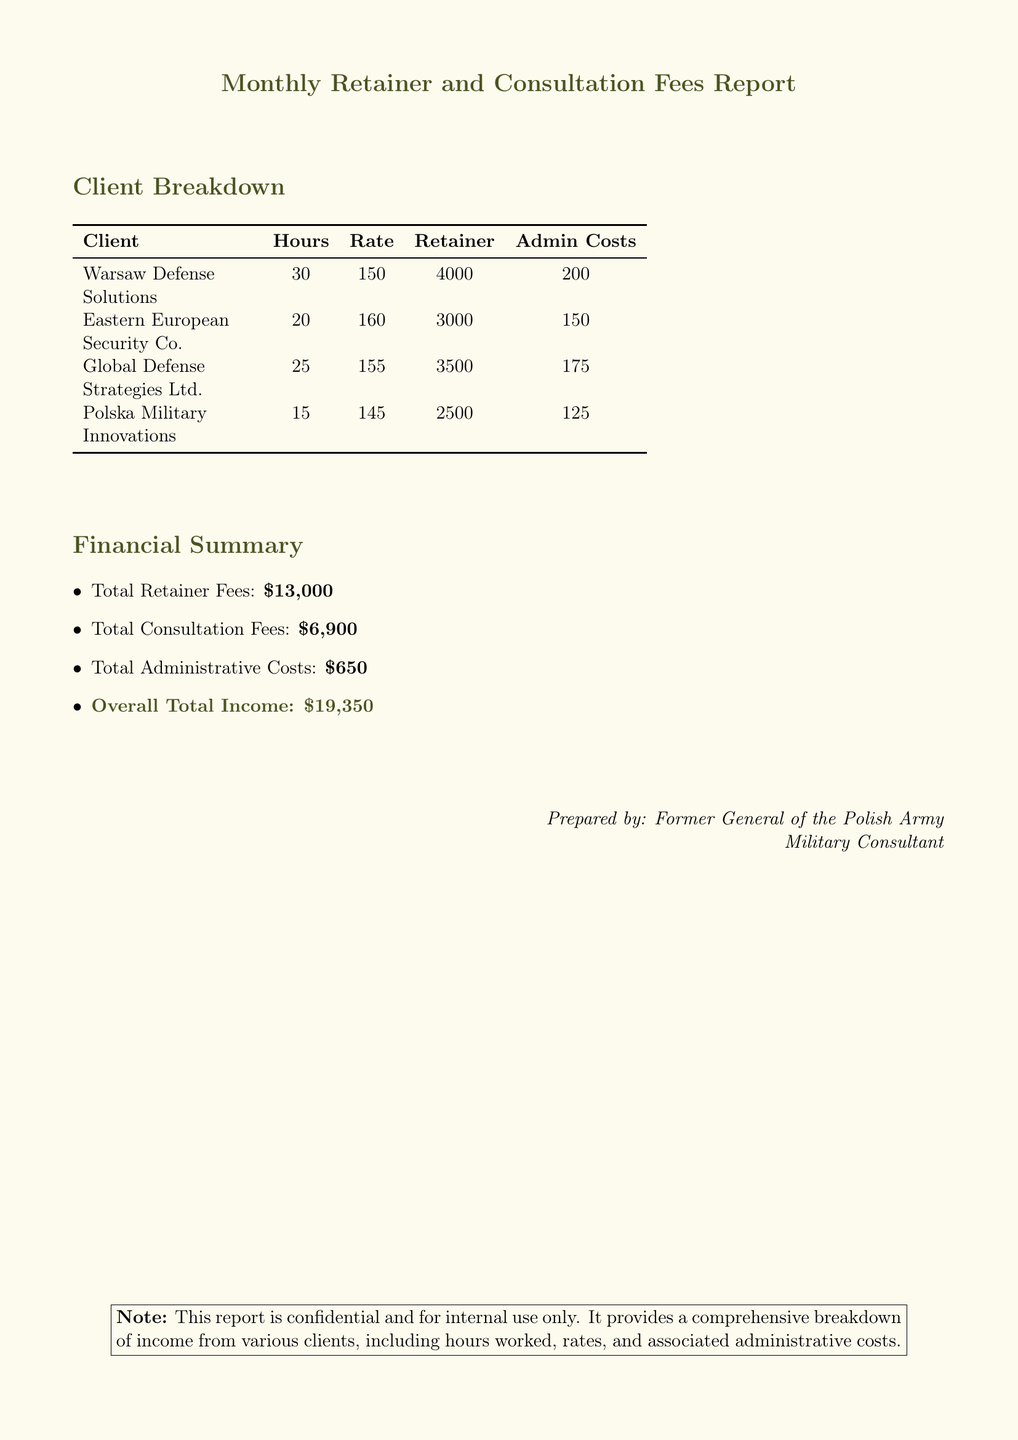What is the total amount of retainer fees? The total amount of retainer fees is explicitly stated in the financial summary of the document.
Answer: $13,000 How many hours were worked for Warsaw Defense Solutions? The number of hours worked for each client is listed in the client breakdown section of the document.
Answer: 30 What is the hourly rate for Eastern European Security Co.? The hourly rate for each client is found in the client breakdown table.
Answer: $160 What are the administrative costs associated with Global Defense Strategies Ltd.? The administrative costs for each client are presented in the client breakdown section, detailing costs per client.
Answer: $175 What is the overall total income? The overall total income represents the sum of all income sources mentioned in the financial summary.
Answer: $19,350 Which client had the lowest administrative costs? By analyzing the administrative costs provided for each client, one can determine which client had the lowest.
Answer: Polska Military Innovations How much consultation income was earned from all clients combined? The total consultation income is specifically mentioned in the financial summary of the document.
Answer: $6,900 What is the retainer fee for Polska Military Innovations? The retainer fee for each client is indicated in the client breakdown table.
Answer: $2,500 What color is used for the document title? The color specified for the title in the document formatting is mentioned in the code.
Answer: Military green 